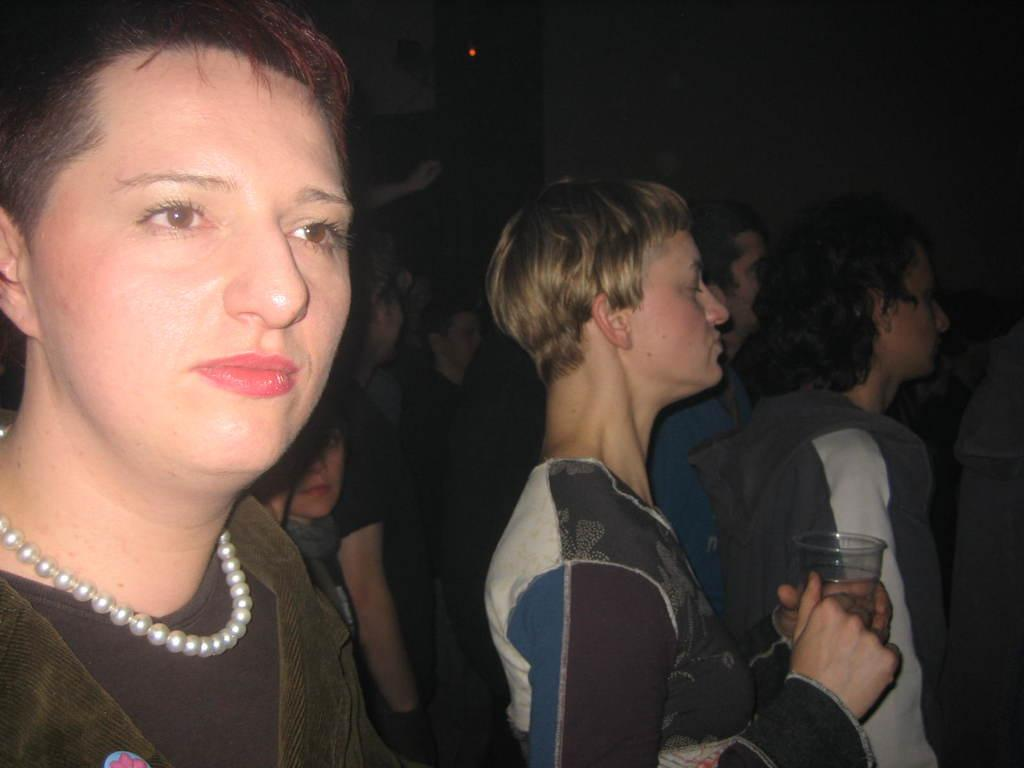What is the person in the image doing? The person is standing in the image and holding a glass. Are there any other people in the image? Yes, there is a group of people standing in the image. What can be seen in the background of the image? There is a wall in the background of the image. Is there anything attached to the wall? Yes, there is a device on the wall. What type of stick is the person using to coach the group of people in the image? There is no stick or coaching activity present in the image. 